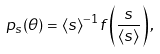<formula> <loc_0><loc_0><loc_500><loc_500>p _ { s } ( \theta ) = \langle s \rangle ^ { - 1 } f \left ( \frac { s } { \langle s \rangle } \right ) ,</formula> 